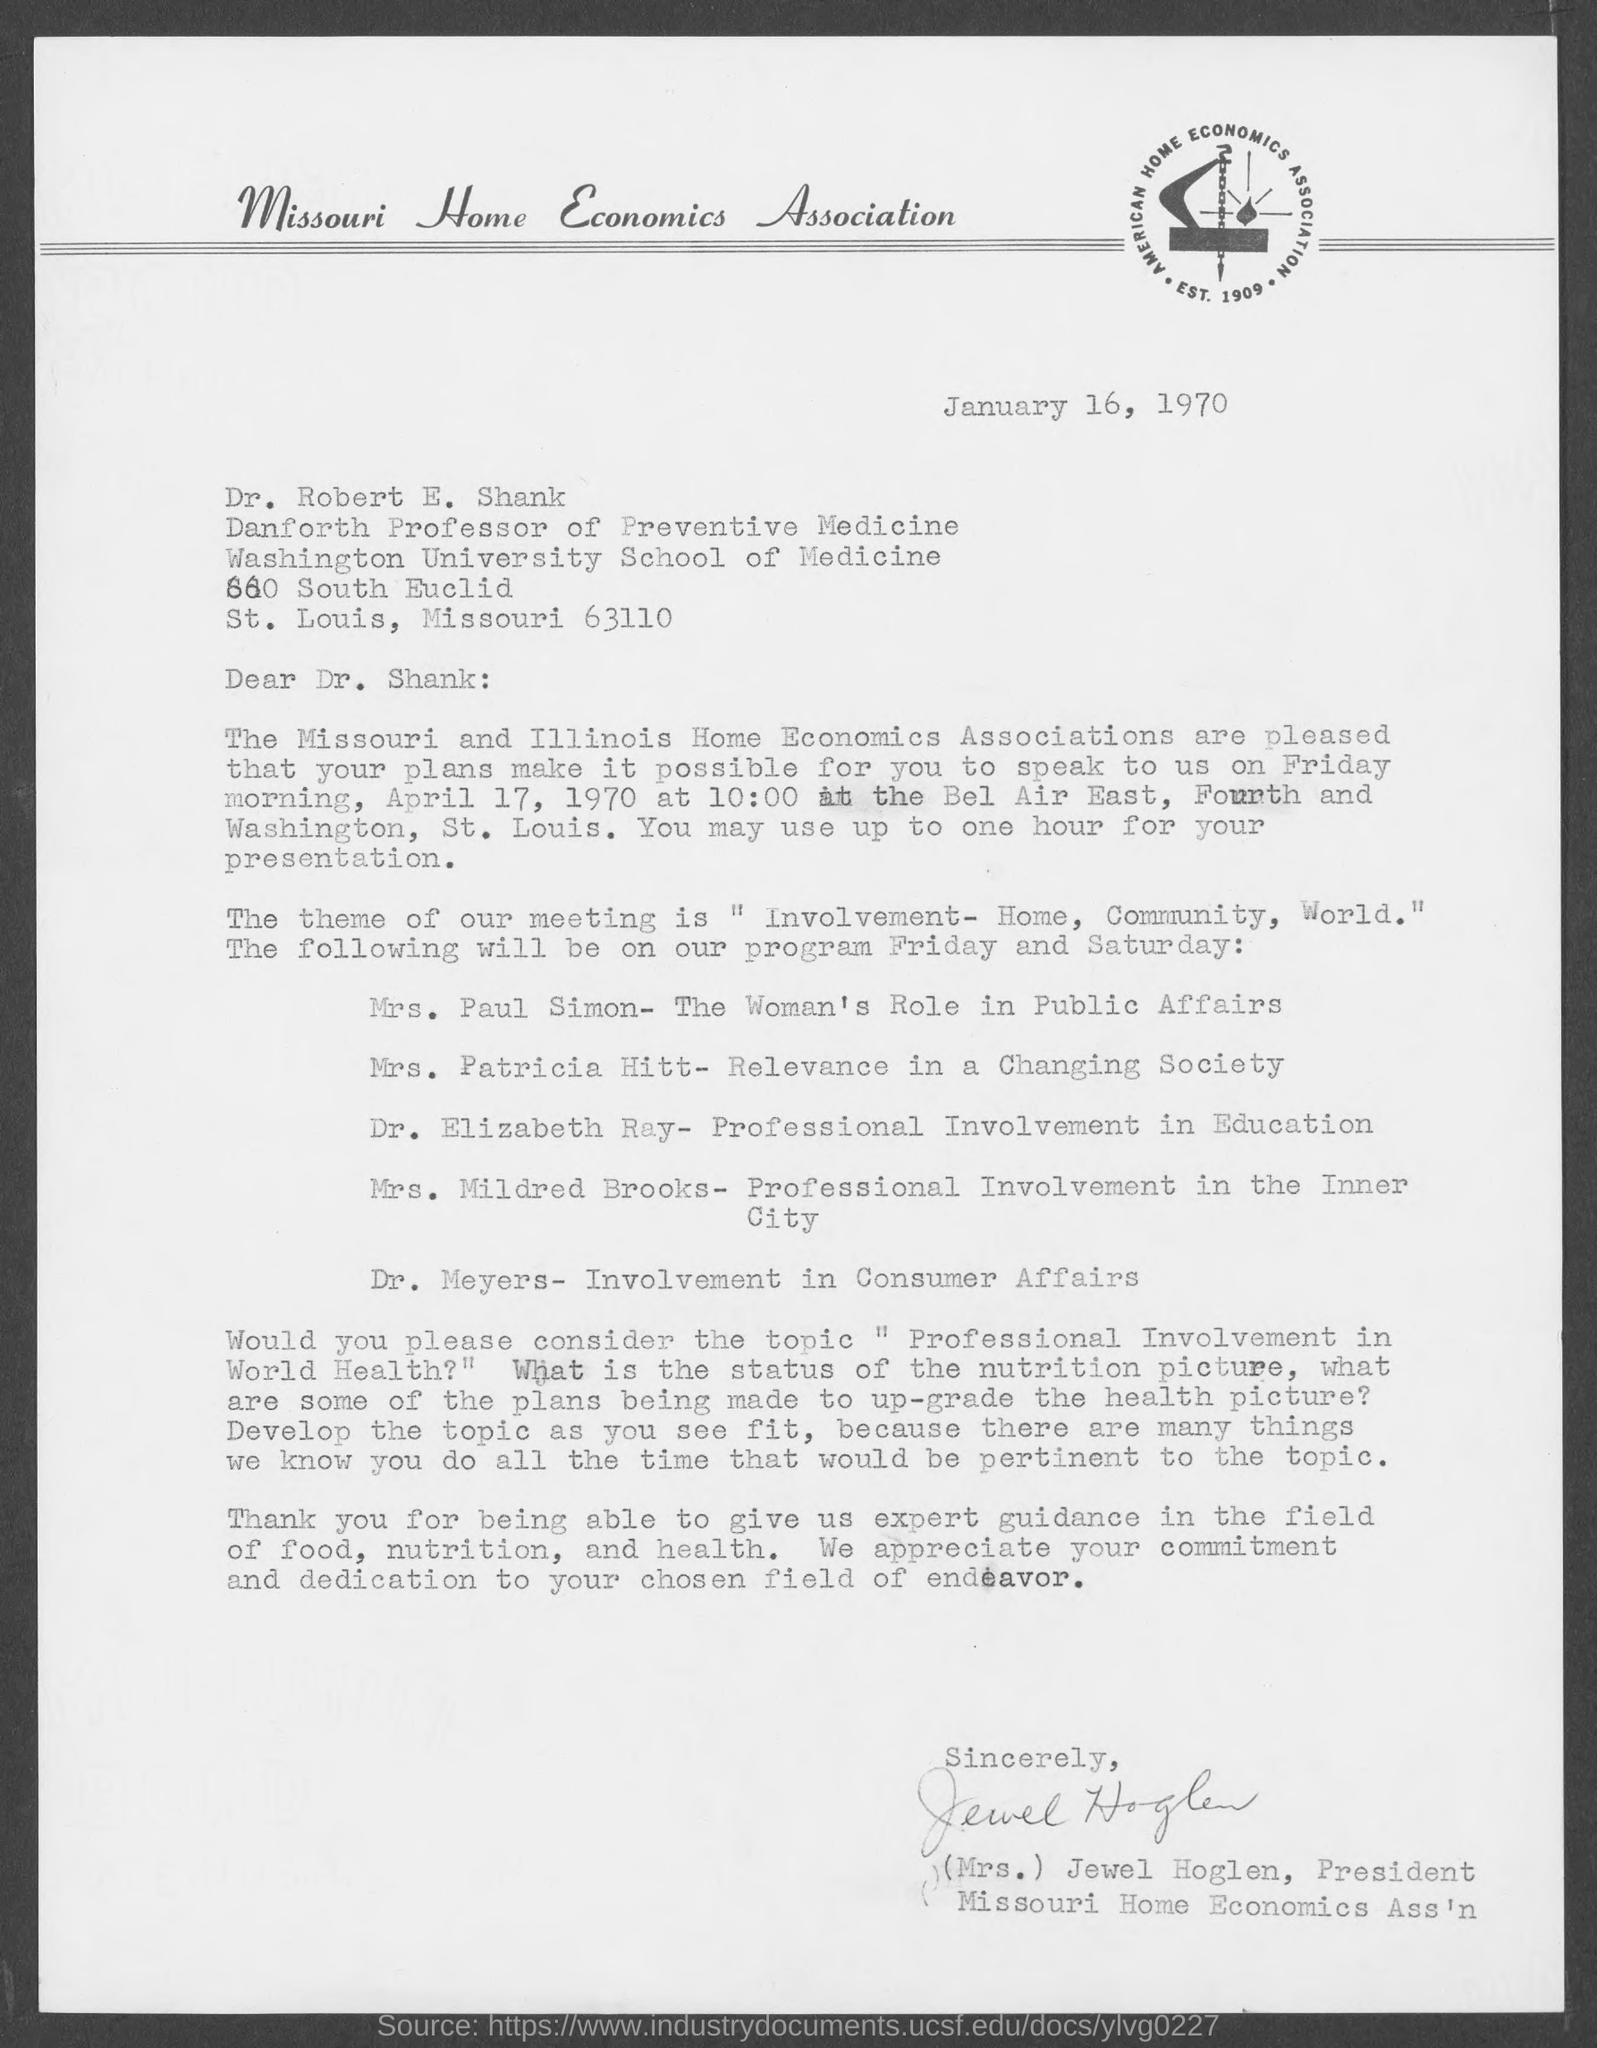Outline some significant characteristics in this image. The letter is addressed to Dr. Robert E. Shank. Dr. Robert E. Shank holds the position of Danforth Professor of Preventive Medicine. Mrs. Jewel Hoglen holds the position of President at the Missouri Home Economics Association. Mrs. Jewel Hoglen wrote this letter. 